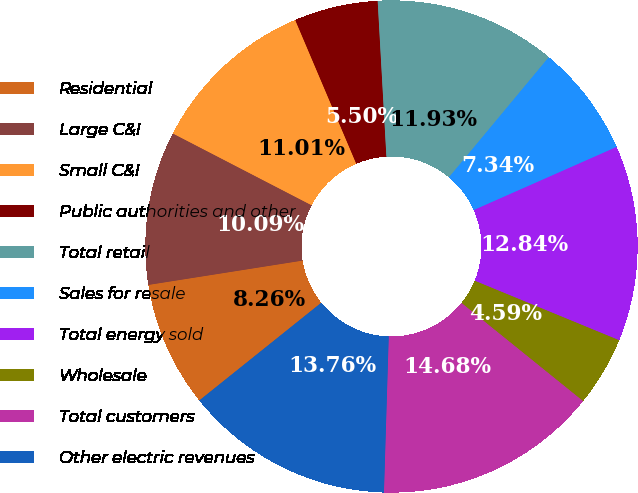Convert chart to OTSL. <chart><loc_0><loc_0><loc_500><loc_500><pie_chart><fcel>Residential<fcel>Large C&I<fcel>Small C&I<fcel>Public authorities and other<fcel>Total retail<fcel>Sales for resale<fcel>Total energy sold<fcel>Wholesale<fcel>Total customers<fcel>Other electric revenues<nl><fcel>8.26%<fcel>10.09%<fcel>11.01%<fcel>5.5%<fcel>11.93%<fcel>7.34%<fcel>12.84%<fcel>4.59%<fcel>14.68%<fcel>13.76%<nl></chart> 